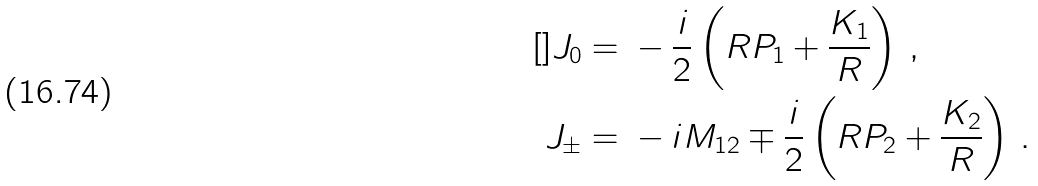Convert formula to latex. <formula><loc_0><loc_0><loc_500><loc_500>[ ] J _ { 0 } = & \ - \frac { i } { 2 } \left ( R P _ { 1 } + \frac { K _ { 1 } } { R } \right ) \, , \\ J _ { \pm } = & \ - i M _ { 1 2 } \mp \frac { i } { 2 } \left ( R P _ { 2 } + \frac { K _ { 2 } } { R } \right ) \, .</formula> 